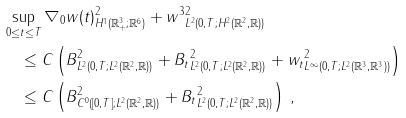Convert formula to latex. <formula><loc_0><loc_0><loc_500><loc_500>& \sup _ { 0 \leq t \leq T } \| \nabla _ { 0 } w ( t ) \| ^ { 2 } _ { H ^ { 1 } ( { \mathbb { R } } ^ { 3 } _ { + } ; { \mathbb { R } } ^ { 6 } ) } + \| w ^ { 3 } \| ^ { 2 } _ { L ^ { 2 } ( 0 , T ; H ^ { 2 } ( { \mathbb { R } } ^ { 2 } , { \mathbb { R } } ) ) } \\ & \quad \leq C \left ( \| B \| ^ { 2 } _ { L ^ { 2 } ( 0 , T ; L ^ { 2 } ( { \mathbb { R } } ^ { 2 } , { \mathbb { R } } ) ) } + \| B _ { t } \| ^ { 2 } _ { L ^ { 2 } ( 0 , T ; L ^ { 2 } ( { \mathbb { R } } ^ { 2 } , { \mathbb { R } } ) ) } + \| w _ { t } \| ^ { 2 } _ { L ^ { \infty } ( 0 , T ; L ^ { 2 } ( { \mathbb { R } } ^ { 3 } , { \mathbb { R } } ^ { 3 } ) ) } \right ) \\ & \quad \leq C \left ( \| B \| ^ { 2 } _ { C ^ { 0 } ( [ 0 , T ] ; L ^ { 2 } ( { \mathbb { R } } ^ { 2 } , { \mathbb { R } } ) ) } + \| B _ { t } \| ^ { 2 } _ { L ^ { 2 } ( 0 , T ; L ^ { 2 } ( { \mathbb { R } } ^ { 2 } , { \mathbb { R } } ) ) } \right ) \, ,</formula> 